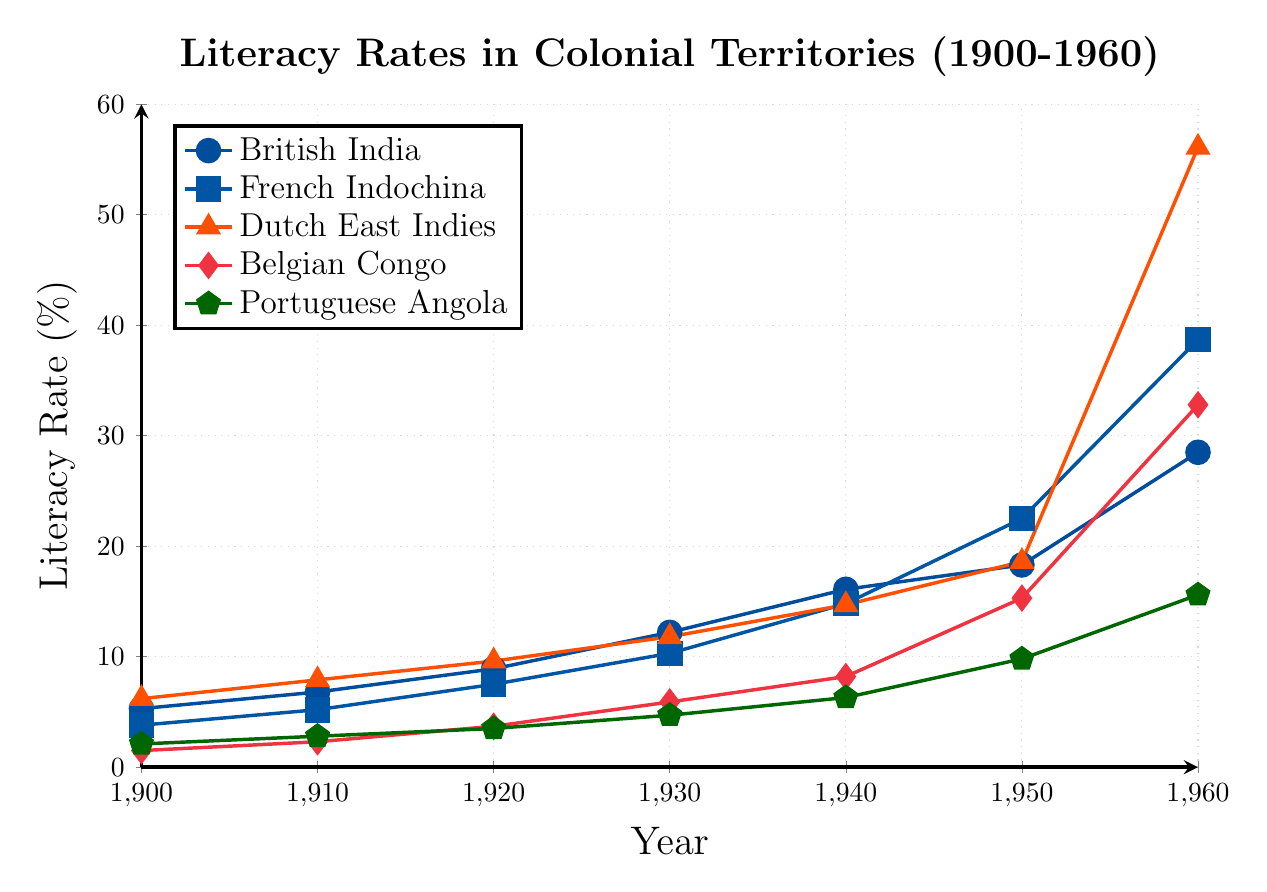What's the average literacy rate in British India across the entire period shown in the figure? To find the average literacy rate, sum up the literacy rates for British India from 1900 to 1960 and divide by the number of data points. The sum is (5.3 + 6.8 + 8.9 + 12.2 + 16.1 + 18.3 + 28.5) = 96.1. There are 7 data points, so the average is 96.1 / 7 ≈ 13.7
Answer: 13.7 Which region had the highest literacy rate in 1960? Look for the literacy rates in 1960 across all regions. British India had 28.5%, French Indochina 38.7%, Dutch East Indies 56.1%, Belgian Congo 32.8%, and Portuguese Angola 15.6%. The highest rate is 56.1% in Dutch East Indies
Answer: Dutch East Indies By how much did the literacy rate in Belgian Congo change between 1940 and 1960? Subtract the literacy rate in 1940 from the rate in 1960 for Belgian Congo. In 1940, it was 8.2%, and in 1960, it was 32.8%. The change is 32.8% - 8.2% = 24.6%
Answer: 24.6% Which two regions had the closest average literacy rates between 1900 and 1960? Calculate the average literacy rates for all five regions and compare them. British India: 13.7%. French Indochina: (3.8 + 5.2 + 7.5 + 10.3 + 14.8 + 22.5 + 38.7) / 7 = 14.13%. Dutch East Indies: (6.2 + 7.9 + 9.6 + 11.8 + 14.7 + 18.6 + 56.1) / 7 = 17.55%. Belgian Congo: (1.5 + 2.3 + 3.7 + 5.9 + 8.2 + 15.3 + 32.8) / 7 = 9.7%. Portuguese Angola: (2.1 + 2.8 + 3.5 + 4.7 + 6.3 + 9.8 + 15.6) / 7 = 6.41%. The closest averages are British India and French Indochina
Answer: British India and French Indochina Evaluate the difference in the literacy rate trends of British India and Dutch East Indies from 1900 to 1960 Examine the slopes visually from the plotted lines. British India's line rises steadily from 5.3% to 28.5% over 60 years. Dutch East Indies rises more sharply, going from 6.2% to 56.1%. The difference in trends indicates Dutch East Indies had a faster literacy growth compared to British India
Answer: Dutch East Indies had faster growth How many percentage points did literacy rates in Portuguese Angola increase from 1900 to 1950? Subtract the literacy rate in 1900 from the rate in 1950 for Portuguese Angola. In 1900, it was 2.1%, and in 1950, it was 9.8%. The increase is 9.8% - 2.1% = 7.7%
Answer: 7.7% What was the year with the sharpest single-decade increase in literacy rates for French Indochina? Compare the decade-by-decade increases for French Indochina. From 1900-1910, the increase is 5.2% - 3.8% = 1.4%. From 1910-1920, 7.5% - 5.2% = 2.3%. From 1920-1930, 10.3% - 7.5% = 2.8%. From 1930-1940, 14.8% - 10.3% = 4.5%. From 1940-1950, 22.5% - 14.8% = 7.7%. From 1950-1960, 38.7% - 22.5% = 16.2%. The sharpest increase was from 1950-1960
Answer: 1950-1960 